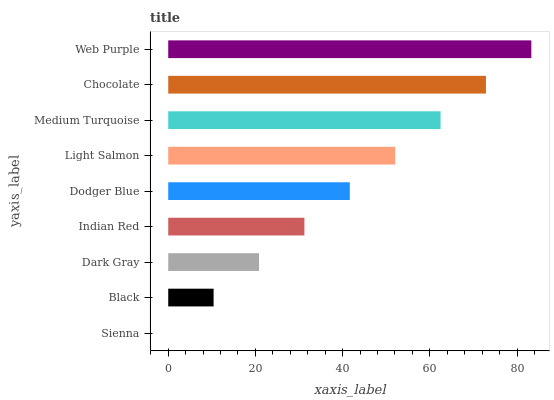Is Sienna the minimum?
Answer yes or no. Yes. Is Web Purple the maximum?
Answer yes or no. Yes. Is Black the minimum?
Answer yes or no. No. Is Black the maximum?
Answer yes or no. No. Is Black greater than Sienna?
Answer yes or no. Yes. Is Sienna less than Black?
Answer yes or no. Yes. Is Sienna greater than Black?
Answer yes or no. No. Is Black less than Sienna?
Answer yes or no. No. Is Dodger Blue the high median?
Answer yes or no. Yes. Is Dodger Blue the low median?
Answer yes or no. Yes. Is Light Salmon the high median?
Answer yes or no. No. Is Medium Turquoise the low median?
Answer yes or no. No. 